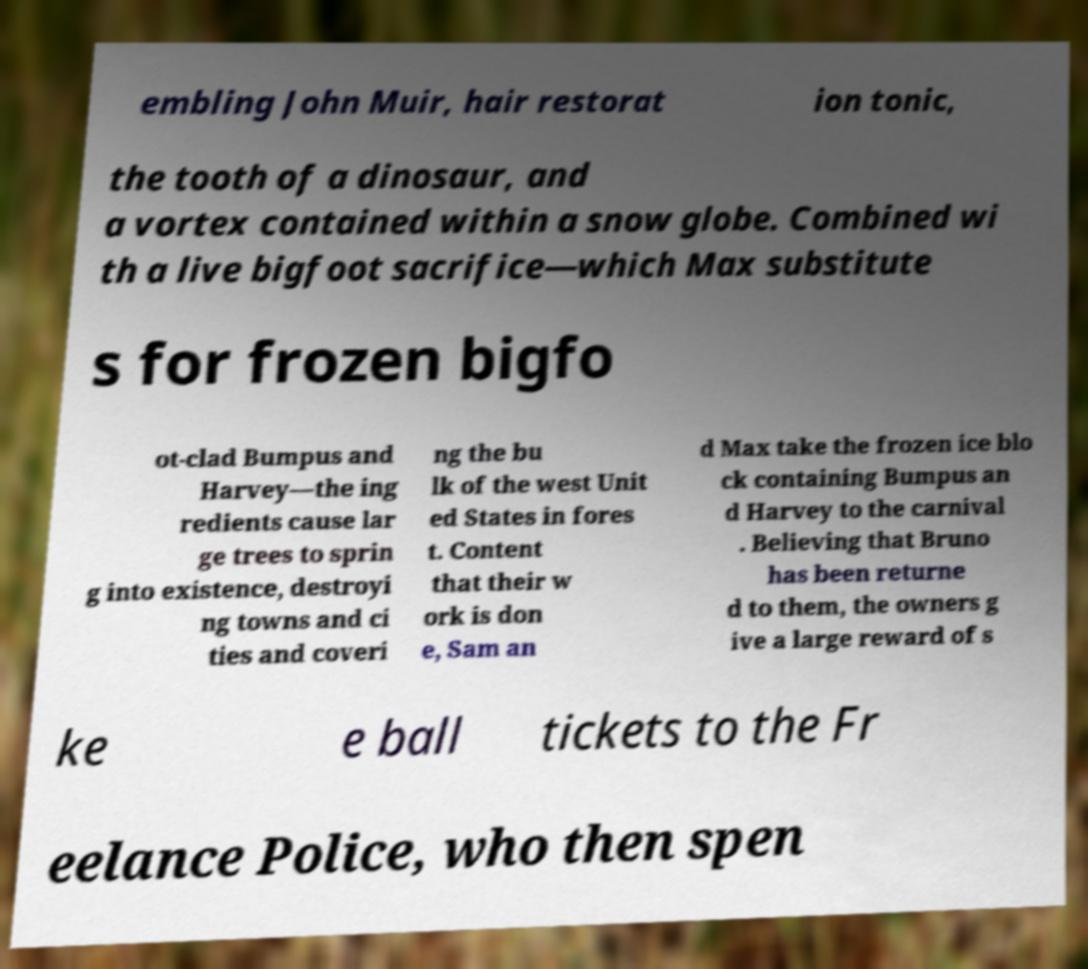Please identify and transcribe the text found in this image. embling John Muir, hair restorat ion tonic, the tooth of a dinosaur, and a vortex contained within a snow globe. Combined wi th a live bigfoot sacrifice—which Max substitute s for frozen bigfo ot-clad Bumpus and Harvey—the ing redients cause lar ge trees to sprin g into existence, destroyi ng towns and ci ties and coveri ng the bu lk of the west Unit ed States in fores t. Content that their w ork is don e, Sam an d Max take the frozen ice blo ck containing Bumpus an d Harvey to the carnival . Believing that Bruno has been returne d to them, the owners g ive a large reward of s ke e ball tickets to the Fr eelance Police, who then spen 